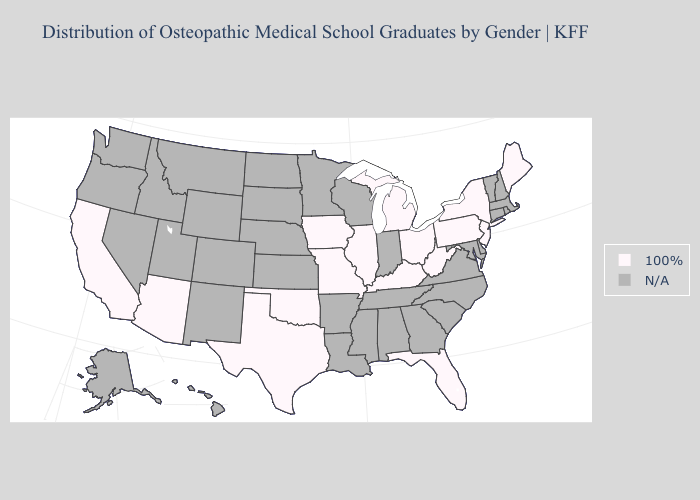What is the value of Connecticut?
Concise answer only. N/A. What is the lowest value in states that border Oklahoma?
Quick response, please. 100%. Name the states that have a value in the range N/A?
Short answer required. Alabama, Alaska, Arkansas, Colorado, Connecticut, Delaware, Georgia, Hawaii, Idaho, Indiana, Kansas, Louisiana, Maryland, Massachusetts, Minnesota, Mississippi, Montana, Nebraska, Nevada, New Hampshire, New Mexico, North Carolina, North Dakota, Oregon, Rhode Island, South Carolina, South Dakota, Tennessee, Utah, Vermont, Virginia, Washington, Wisconsin, Wyoming. Name the states that have a value in the range N/A?
Quick response, please. Alabama, Alaska, Arkansas, Colorado, Connecticut, Delaware, Georgia, Hawaii, Idaho, Indiana, Kansas, Louisiana, Maryland, Massachusetts, Minnesota, Mississippi, Montana, Nebraska, Nevada, New Hampshire, New Mexico, North Carolina, North Dakota, Oregon, Rhode Island, South Carolina, South Dakota, Tennessee, Utah, Vermont, Virginia, Washington, Wisconsin, Wyoming. What is the value of Rhode Island?
Quick response, please. N/A. Name the states that have a value in the range 100%?
Short answer required. Arizona, California, Florida, Illinois, Iowa, Kentucky, Maine, Michigan, Missouri, New Jersey, New York, Ohio, Oklahoma, Pennsylvania, Texas, West Virginia. Is the legend a continuous bar?
Keep it brief. No. What is the lowest value in the USA?
Be succinct. 100%. What is the value of Colorado?
Short answer required. N/A. Name the states that have a value in the range 100%?
Give a very brief answer. Arizona, California, Florida, Illinois, Iowa, Kentucky, Maine, Michigan, Missouri, New Jersey, New York, Ohio, Oklahoma, Pennsylvania, Texas, West Virginia. Which states have the highest value in the USA?
Concise answer only. Arizona, California, Florida, Illinois, Iowa, Kentucky, Maine, Michigan, Missouri, New Jersey, New York, Ohio, Oklahoma, Pennsylvania, Texas, West Virginia. 